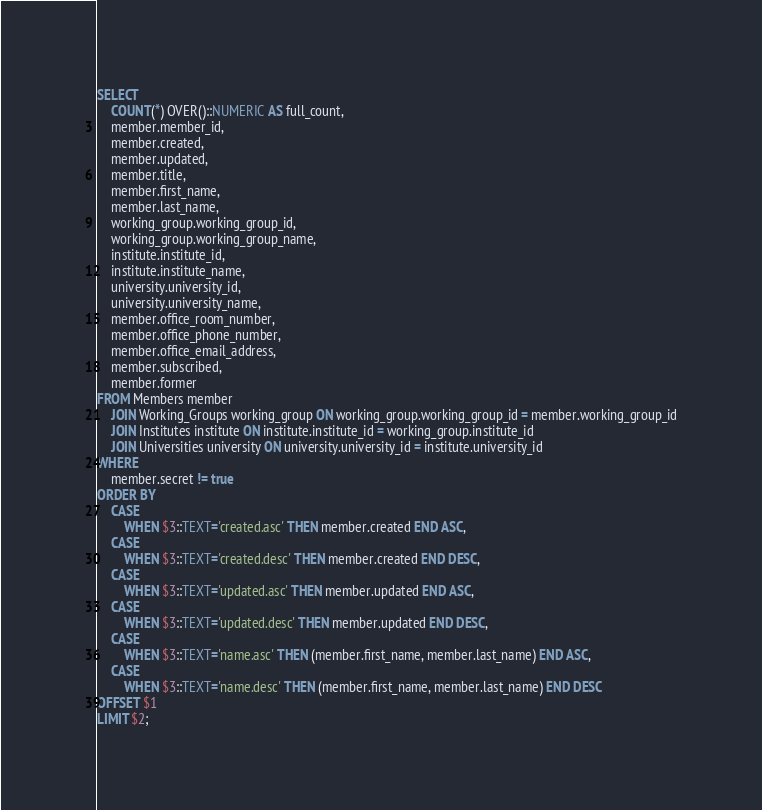<code> <loc_0><loc_0><loc_500><loc_500><_SQL_>SELECT
    COUNT(*) OVER()::NUMERIC AS full_count,
    member.member_id,
    member.created,
    member.updated,
    member.title,
    member.first_name,
    member.last_name,
    working_group.working_group_id,
    working_group.working_group_name,
    institute.institute_id,
    institute.institute_name,
    university.university_id,
    university.university_name,
    member.office_room_number,
    member.office_phone_number,
    member.office_email_address,
    member.subscribed,
    member.former
FROM Members member
    JOIN Working_Groups working_group ON working_group.working_group_id = member.working_group_id
    JOIN Institutes institute ON institute.institute_id = working_group.institute_id
    JOIN Universities university ON university.university_id = institute.university_id
WHERE
    member.secret != true
ORDER BY
    CASE
        WHEN $3::TEXT='created.asc' THEN member.created END ASC,
    CASE
        WHEN $3::TEXT='created.desc' THEN member.created END DESC,
    CASE
        WHEN $3::TEXT='updated.asc' THEN member.updated END ASC,
    CASE
        WHEN $3::TEXT='updated.desc' THEN member.updated END DESC,
    CASE
        WHEN $3::TEXT='name.asc' THEN (member.first_name, member.last_name) END ASC,
    CASE
        WHEN $3::TEXT='name.desc' THEN (member.first_name, member.last_name) END DESC
OFFSET $1
LIMIT $2;
</code> 